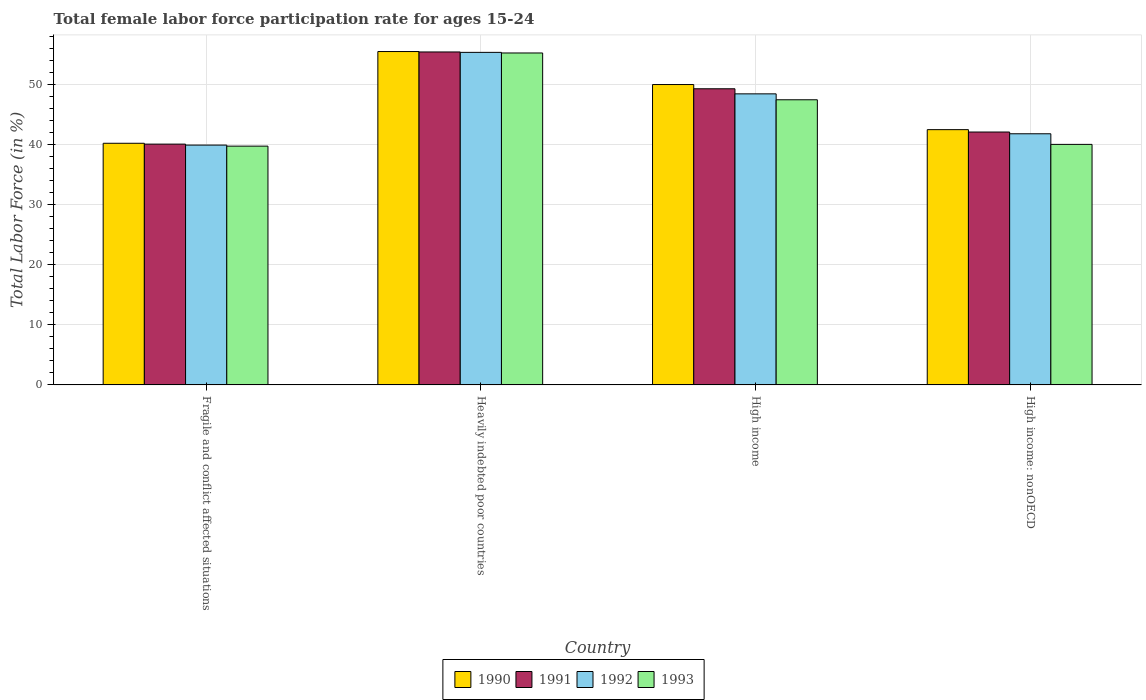How many different coloured bars are there?
Keep it short and to the point. 4. How many bars are there on the 4th tick from the right?
Give a very brief answer. 4. What is the label of the 2nd group of bars from the left?
Ensure brevity in your answer.  Heavily indebted poor countries. What is the female labor force participation rate in 1990 in Heavily indebted poor countries?
Keep it short and to the point. 55.53. Across all countries, what is the maximum female labor force participation rate in 1991?
Give a very brief answer. 55.46. Across all countries, what is the minimum female labor force participation rate in 1992?
Your answer should be very brief. 39.95. In which country was the female labor force participation rate in 1993 maximum?
Make the answer very short. Heavily indebted poor countries. In which country was the female labor force participation rate in 1992 minimum?
Provide a succinct answer. Fragile and conflict affected situations. What is the total female labor force participation rate in 1991 in the graph?
Make the answer very short. 187.02. What is the difference between the female labor force participation rate in 1992 in Heavily indebted poor countries and that in High income: nonOECD?
Provide a short and direct response. 13.56. What is the difference between the female labor force participation rate in 1993 in High income: nonOECD and the female labor force participation rate in 1990 in Fragile and conflict affected situations?
Provide a succinct answer. -0.18. What is the average female labor force participation rate in 1993 per country?
Offer a terse response. 45.66. What is the difference between the female labor force participation rate of/in 1991 and female labor force participation rate of/in 1990 in High income?
Offer a terse response. -0.71. What is the ratio of the female labor force participation rate in 1993 in Heavily indebted poor countries to that in High income: nonOECD?
Your response must be concise. 1.38. Is the female labor force participation rate in 1990 in Fragile and conflict affected situations less than that in Heavily indebted poor countries?
Keep it short and to the point. Yes. What is the difference between the highest and the second highest female labor force participation rate in 1992?
Provide a short and direct response. 6.65. What is the difference between the highest and the lowest female labor force participation rate in 1992?
Offer a very short reply. 15.44. In how many countries, is the female labor force participation rate in 1990 greater than the average female labor force participation rate in 1990 taken over all countries?
Offer a terse response. 2. What does the 3rd bar from the left in High income: nonOECD represents?
Keep it short and to the point. 1992. What does the 2nd bar from the right in Heavily indebted poor countries represents?
Offer a terse response. 1992. How many bars are there?
Make the answer very short. 16. Are all the bars in the graph horizontal?
Give a very brief answer. No. How many countries are there in the graph?
Offer a terse response. 4. Are the values on the major ticks of Y-axis written in scientific E-notation?
Provide a short and direct response. No. Does the graph contain any zero values?
Your answer should be compact. No. Does the graph contain grids?
Provide a short and direct response. Yes. How many legend labels are there?
Provide a succinct answer. 4. How are the legend labels stacked?
Offer a very short reply. Horizontal. What is the title of the graph?
Provide a succinct answer. Total female labor force participation rate for ages 15-24. What is the Total Labor Force (in %) in 1990 in Fragile and conflict affected situations?
Offer a very short reply. 40.25. What is the Total Labor Force (in %) in 1991 in Fragile and conflict affected situations?
Provide a short and direct response. 40.11. What is the Total Labor Force (in %) of 1992 in Fragile and conflict affected situations?
Ensure brevity in your answer.  39.95. What is the Total Labor Force (in %) in 1993 in Fragile and conflict affected situations?
Your response must be concise. 39.77. What is the Total Labor Force (in %) of 1990 in Heavily indebted poor countries?
Keep it short and to the point. 55.53. What is the Total Labor Force (in %) of 1991 in Heavily indebted poor countries?
Keep it short and to the point. 55.46. What is the Total Labor Force (in %) of 1992 in Heavily indebted poor countries?
Keep it short and to the point. 55.39. What is the Total Labor Force (in %) in 1993 in Heavily indebted poor countries?
Your answer should be compact. 55.29. What is the Total Labor Force (in %) of 1990 in High income?
Ensure brevity in your answer.  50.03. What is the Total Labor Force (in %) in 1991 in High income?
Provide a short and direct response. 49.33. What is the Total Labor Force (in %) of 1992 in High income?
Offer a terse response. 48.48. What is the Total Labor Force (in %) of 1993 in High income?
Your response must be concise. 47.5. What is the Total Labor Force (in %) of 1990 in High income: nonOECD?
Offer a terse response. 42.52. What is the Total Labor Force (in %) in 1991 in High income: nonOECD?
Your answer should be compact. 42.12. What is the Total Labor Force (in %) in 1992 in High income: nonOECD?
Keep it short and to the point. 41.83. What is the Total Labor Force (in %) in 1993 in High income: nonOECD?
Give a very brief answer. 40.07. Across all countries, what is the maximum Total Labor Force (in %) of 1990?
Your answer should be very brief. 55.53. Across all countries, what is the maximum Total Labor Force (in %) in 1991?
Your answer should be very brief. 55.46. Across all countries, what is the maximum Total Labor Force (in %) in 1992?
Keep it short and to the point. 55.39. Across all countries, what is the maximum Total Labor Force (in %) of 1993?
Keep it short and to the point. 55.29. Across all countries, what is the minimum Total Labor Force (in %) in 1990?
Make the answer very short. 40.25. Across all countries, what is the minimum Total Labor Force (in %) of 1991?
Your response must be concise. 40.11. Across all countries, what is the minimum Total Labor Force (in %) of 1992?
Provide a short and direct response. 39.95. Across all countries, what is the minimum Total Labor Force (in %) in 1993?
Make the answer very short. 39.77. What is the total Total Labor Force (in %) in 1990 in the graph?
Ensure brevity in your answer.  188.33. What is the total Total Labor Force (in %) of 1991 in the graph?
Make the answer very short. 187.02. What is the total Total Labor Force (in %) in 1992 in the graph?
Your answer should be compact. 185.65. What is the total Total Labor Force (in %) of 1993 in the graph?
Provide a succinct answer. 182.62. What is the difference between the Total Labor Force (in %) in 1990 in Fragile and conflict affected situations and that in Heavily indebted poor countries?
Offer a terse response. -15.28. What is the difference between the Total Labor Force (in %) of 1991 in Fragile and conflict affected situations and that in Heavily indebted poor countries?
Keep it short and to the point. -15.35. What is the difference between the Total Labor Force (in %) in 1992 in Fragile and conflict affected situations and that in Heavily indebted poor countries?
Your response must be concise. -15.44. What is the difference between the Total Labor Force (in %) of 1993 in Fragile and conflict affected situations and that in Heavily indebted poor countries?
Your response must be concise. -15.52. What is the difference between the Total Labor Force (in %) of 1990 in Fragile and conflict affected situations and that in High income?
Make the answer very short. -9.78. What is the difference between the Total Labor Force (in %) in 1991 in Fragile and conflict affected situations and that in High income?
Ensure brevity in your answer.  -9.22. What is the difference between the Total Labor Force (in %) of 1992 in Fragile and conflict affected situations and that in High income?
Your response must be concise. -8.53. What is the difference between the Total Labor Force (in %) in 1993 in Fragile and conflict affected situations and that in High income?
Make the answer very short. -7.72. What is the difference between the Total Labor Force (in %) of 1990 in Fragile and conflict affected situations and that in High income: nonOECD?
Your response must be concise. -2.27. What is the difference between the Total Labor Force (in %) in 1991 in Fragile and conflict affected situations and that in High income: nonOECD?
Provide a succinct answer. -2.01. What is the difference between the Total Labor Force (in %) in 1992 in Fragile and conflict affected situations and that in High income: nonOECD?
Keep it short and to the point. -1.88. What is the difference between the Total Labor Force (in %) in 1993 in Fragile and conflict affected situations and that in High income: nonOECD?
Provide a short and direct response. -0.29. What is the difference between the Total Labor Force (in %) in 1990 in Heavily indebted poor countries and that in High income?
Your answer should be very brief. 5.5. What is the difference between the Total Labor Force (in %) of 1991 in Heavily indebted poor countries and that in High income?
Your answer should be very brief. 6.13. What is the difference between the Total Labor Force (in %) in 1992 in Heavily indebted poor countries and that in High income?
Your response must be concise. 6.91. What is the difference between the Total Labor Force (in %) of 1993 in Heavily indebted poor countries and that in High income?
Your answer should be compact. 7.79. What is the difference between the Total Labor Force (in %) in 1990 in Heavily indebted poor countries and that in High income: nonOECD?
Offer a very short reply. 13.01. What is the difference between the Total Labor Force (in %) in 1991 in Heavily indebted poor countries and that in High income: nonOECD?
Ensure brevity in your answer.  13.34. What is the difference between the Total Labor Force (in %) in 1992 in Heavily indebted poor countries and that in High income: nonOECD?
Your response must be concise. 13.56. What is the difference between the Total Labor Force (in %) of 1993 in Heavily indebted poor countries and that in High income: nonOECD?
Your answer should be compact. 15.22. What is the difference between the Total Labor Force (in %) of 1990 in High income and that in High income: nonOECD?
Give a very brief answer. 7.52. What is the difference between the Total Labor Force (in %) of 1991 in High income and that in High income: nonOECD?
Provide a short and direct response. 7.2. What is the difference between the Total Labor Force (in %) in 1992 in High income and that in High income: nonOECD?
Your answer should be compact. 6.65. What is the difference between the Total Labor Force (in %) in 1993 in High income and that in High income: nonOECD?
Ensure brevity in your answer.  7.43. What is the difference between the Total Labor Force (in %) of 1990 in Fragile and conflict affected situations and the Total Labor Force (in %) of 1991 in Heavily indebted poor countries?
Make the answer very short. -15.21. What is the difference between the Total Labor Force (in %) of 1990 in Fragile and conflict affected situations and the Total Labor Force (in %) of 1992 in Heavily indebted poor countries?
Your answer should be compact. -15.14. What is the difference between the Total Labor Force (in %) in 1990 in Fragile and conflict affected situations and the Total Labor Force (in %) in 1993 in Heavily indebted poor countries?
Provide a succinct answer. -15.04. What is the difference between the Total Labor Force (in %) of 1991 in Fragile and conflict affected situations and the Total Labor Force (in %) of 1992 in Heavily indebted poor countries?
Offer a terse response. -15.28. What is the difference between the Total Labor Force (in %) of 1991 in Fragile and conflict affected situations and the Total Labor Force (in %) of 1993 in Heavily indebted poor countries?
Your answer should be very brief. -15.18. What is the difference between the Total Labor Force (in %) of 1992 in Fragile and conflict affected situations and the Total Labor Force (in %) of 1993 in Heavily indebted poor countries?
Keep it short and to the point. -15.34. What is the difference between the Total Labor Force (in %) in 1990 in Fragile and conflict affected situations and the Total Labor Force (in %) in 1991 in High income?
Make the answer very short. -9.08. What is the difference between the Total Labor Force (in %) of 1990 in Fragile and conflict affected situations and the Total Labor Force (in %) of 1992 in High income?
Offer a very short reply. -8.23. What is the difference between the Total Labor Force (in %) in 1990 in Fragile and conflict affected situations and the Total Labor Force (in %) in 1993 in High income?
Give a very brief answer. -7.24. What is the difference between the Total Labor Force (in %) in 1991 in Fragile and conflict affected situations and the Total Labor Force (in %) in 1992 in High income?
Make the answer very short. -8.37. What is the difference between the Total Labor Force (in %) of 1991 in Fragile and conflict affected situations and the Total Labor Force (in %) of 1993 in High income?
Your answer should be very brief. -7.38. What is the difference between the Total Labor Force (in %) in 1992 in Fragile and conflict affected situations and the Total Labor Force (in %) in 1993 in High income?
Your answer should be compact. -7.55. What is the difference between the Total Labor Force (in %) in 1990 in Fragile and conflict affected situations and the Total Labor Force (in %) in 1991 in High income: nonOECD?
Offer a terse response. -1.87. What is the difference between the Total Labor Force (in %) in 1990 in Fragile and conflict affected situations and the Total Labor Force (in %) in 1992 in High income: nonOECD?
Ensure brevity in your answer.  -1.58. What is the difference between the Total Labor Force (in %) in 1990 in Fragile and conflict affected situations and the Total Labor Force (in %) in 1993 in High income: nonOECD?
Offer a very short reply. 0.18. What is the difference between the Total Labor Force (in %) in 1991 in Fragile and conflict affected situations and the Total Labor Force (in %) in 1992 in High income: nonOECD?
Provide a short and direct response. -1.72. What is the difference between the Total Labor Force (in %) in 1991 in Fragile and conflict affected situations and the Total Labor Force (in %) in 1993 in High income: nonOECD?
Your answer should be very brief. 0.04. What is the difference between the Total Labor Force (in %) of 1992 in Fragile and conflict affected situations and the Total Labor Force (in %) of 1993 in High income: nonOECD?
Ensure brevity in your answer.  -0.12. What is the difference between the Total Labor Force (in %) in 1990 in Heavily indebted poor countries and the Total Labor Force (in %) in 1991 in High income?
Your response must be concise. 6.2. What is the difference between the Total Labor Force (in %) in 1990 in Heavily indebted poor countries and the Total Labor Force (in %) in 1992 in High income?
Ensure brevity in your answer.  7.05. What is the difference between the Total Labor Force (in %) of 1990 in Heavily indebted poor countries and the Total Labor Force (in %) of 1993 in High income?
Provide a short and direct response. 8.03. What is the difference between the Total Labor Force (in %) of 1991 in Heavily indebted poor countries and the Total Labor Force (in %) of 1992 in High income?
Provide a short and direct response. 6.98. What is the difference between the Total Labor Force (in %) of 1991 in Heavily indebted poor countries and the Total Labor Force (in %) of 1993 in High income?
Your response must be concise. 7.96. What is the difference between the Total Labor Force (in %) in 1992 in Heavily indebted poor countries and the Total Labor Force (in %) in 1993 in High income?
Offer a very short reply. 7.9. What is the difference between the Total Labor Force (in %) in 1990 in Heavily indebted poor countries and the Total Labor Force (in %) in 1991 in High income: nonOECD?
Offer a terse response. 13.4. What is the difference between the Total Labor Force (in %) in 1990 in Heavily indebted poor countries and the Total Labor Force (in %) in 1992 in High income: nonOECD?
Your response must be concise. 13.7. What is the difference between the Total Labor Force (in %) of 1990 in Heavily indebted poor countries and the Total Labor Force (in %) of 1993 in High income: nonOECD?
Give a very brief answer. 15.46. What is the difference between the Total Labor Force (in %) of 1991 in Heavily indebted poor countries and the Total Labor Force (in %) of 1992 in High income: nonOECD?
Provide a short and direct response. 13.63. What is the difference between the Total Labor Force (in %) of 1991 in Heavily indebted poor countries and the Total Labor Force (in %) of 1993 in High income: nonOECD?
Your answer should be very brief. 15.39. What is the difference between the Total Labor Force (in %) in 1992 in Heavily indebted poor countries and the Total Labor Force (in %) in 1993 in High income: nonOECD?
Ensure brevity in your answer.  15.33. What is the difference between the Total Labor Force (in %) in 1990 in High income and the Total Labor Force (in %) in 1991 in High income: nonOECD?
Make the answer very short. 7.91. What is the difference between the Total Labor Force (in %) in 1990 in High income and the Total Labor Force (in %) in 1992 in High income: nonOECD?
Keep it short and to the point. 8.2. What is the difference between the Total Labor Force (in %) in 1990 in High income and the Total Labor Force (in %) in 1993 in High income: nonOECD?
Keep it short and to the point. 9.97. What is the difference between the Total Labor Force (in %) in 1991 in High income and the Total Labor Force (in %) in 1992 in High income: nonOECD?
Provide a short and direct response. 7.5. What is the difference between the Total Labor Force (in %) of 1991 in High income and the Total Labor Force (in %) of 1993 in High income: nonOECD?
Offer a very short reply. 9.26. What is the difference between the Total Labor Force (in %) in 1992 in High income and the Total Labor Force (in %) in 1993 in High income: nonOECD?
Offer a terse response. 8.42. What is the average Total Labor Force (in %) of 1990 per country?
Offer a very short reply. 47.08. What is the average Total Labor Force (in %) in 1991 per country?
Ensure brevity in your answer.  46.76. What is the average Total Labor Force (in %) of 1992 per country?
Offer a terse response. 46.41. What is the average Total Labor Force (in %) in 1993 per country?
Provide a short and direct response. 45.66. What is the difference between the Total Labor Force (in %) in 1990 and Total Labor Force (in %) in 1991 in Fragile and conflict affected situations?
Ensure brevity in your answer.  0.14. What is the difference between the Total Labor Force (in %) of 1990 and Total Labor Force (in %) of 1992 in Fragile and conflict affected situations?
Ensure brevity in your answer.  0.3. What is the difference between the Total Labor Force (in %) in 1990 and Total Labor Force (in %) in 1993 in Fragile and conflict affected situations?
Give a very brief answer. 0.48. What is the difference between the Total Labor Force (in %) in 1991 and Total Labor Force (in %) in 1992 in Fragile and conflict affected situations?
Provide a short and direct response. 0.16. What is the difference between the Total Labor Force (in %) in 1991 and Total Labor Force (in %) in 1993 in Fragile and conflict affected situations?
Offer a terse response. 0.34. What is the difference between the Total Labor Force (in %) of 1992 and Total Labor Force (in %) of 1993 in Fragile and conflict affected situations?
Provide a succinct answer. 0.18. What is the difference between the Total Labor Force (in %) in 1990 and Total Labor Force (in %) in 1991 in Heavily indebted poor countries?
Offer a very short reply. 0.07. What is the difference between the Total Labor Force (in %) in 1990 and Total Labor Force (in %) in 1992 in Heavily indebted poor countries?
Your answer should be compact. 0.14. What is the difference between the Total Labor Force (in %) of 1990 and Total Labor Force (in %) of 1993 in Heavily indebted poor countries?
Your answer should be very brief. 0.24. What is the difference between the Total Labor Force (in %) in 1991 and Total Labor Force (in %) in 1992 in Heavily indebted poor countries?
Offer a terse response. 0.07. What is the difference between the Total Labor Force (in %) in 1991 and Total Labor Force (in %) in 1993 in Heavily indebted poor countries?
Give a very brief answer. 0.17. What is the difference between the Total Labor Force (in %) of 1992 and Total Labor Force (in %) of 1993 in Heavily indebted poor countries?
Keep it short and to the point. 0.1. What is the difference between the Total Labor Force (in %) in 1990 and Total Labor Force (in %) in 1991 in High income?
Provide a short and direct response. 0.71. What is the difference between the Total Labor Force (in %) in 1990 and Total Labor Force (in %) in 1992 in High income?
Give a very brief answer. 1.55. What is the difference between the Total Labor Force (in %) of 1990 and Total Labor Force (in %) of 1993 in High income?
Ensure brevity in your answer.  2.54. What is the difference between the Total Labor Force (in %) in 1991 and Total Labor Force (in %) in 1992 in High income?
Provide a succinct answer. 0.85. What is the difference between the Total Labor Force (in %) of 1991 and Total Labor Force (in %) of 1993 in High income?
Your response must be concise. 1.83. What is the difference between the Total Labor Force (in %) in 1992 and Total Labor Force (in %) in 1993 in High income?
Give a very brief answer. 0.99. What is the difference between the Total Labor Force (in %) of 1990 and Total Labor Force (in %) of 1991 in High income: nonOECD?
Your answer should be very brief. 0.39. What is the difference between the Total Labor Force (in %) in 1990 and Total Labor Force (in %) in 1992 in High income: nonOECD?
Your answer should be compact. 0.69. What is the difference between the Total Labor Force (in %) of 1990 and Total Labor Force (in %) of 1993 in High income: nonOECD?
Provide a succinct answer. 2.45. What is the difference between the Total Labor Force (in %) of 1991 and Total Labor Force (in %) of 1992 in High income: nonOECD?
Give a very brief answer. 0.29. What is the difference between the Total Labor Force (in %) in 1991 and Total Labor Force (in %) in 1993 in High income: nonOECD?
Offer a very short reply. 2.06. What is the difference between the Total Labor Force (in %) in 1992 and Total Labor Force (in %) in 1993 in High income: nonOECD?
Your answer should be very brief. 1.77. What is the ratio of the Total Labor Force (in %) of 1990 in Fragile and conflict affected situations to that in Heavily indebted poor countries?
Keep it short and to the point. 0.72. What is the ratio of the Total Labor Force (in %) of 1991 in Fragile and conflict affected situations to that in Heavily indebted poor countries?
Provide a short and direct response. 0.72. What is the ratio of the Total Labor Force (in %) of 1992 in Fragile and conflict affected situations to that in Heavily indebted poor countries?
Give a very brief answer. 0.72. What is the ratio of the Total Labor Force (in %) in 1993 in Fragile and conflict affected situations to that in Heavily indebted poor countries?
Provide a succinct answer. 0.72. What is the ratio of the Total Labor Force (in %) in 1990 in Fragile and conflict affected situations to that in High income?
Your answer should be very brief. 0.8. What is the ratio of the Total Labor Force (in %) of 1991 in Fragile and conflict affected situations to that in High income?
Your answer should be very brief. 0.81. What is the ratio of the Total Labor Force (in %) of 1992 in Fragile and conflict affected situations to that in High income?
Offer a very short reply. 0.82. What is the ratio of the Total Labor Force (in %) of 1993 in Fragile and conflict affected situations to that in High income?
Offer a very short reply. 0.84. What is the ratio of the Total Labor Force (in %) in 1990 in Fragile and conflict affected situations to that in High income: nonOECD?
Give a very brief answer. 0.95. What is the ratio of the Total Labor Force (in %) of 1991 in Fragile and conflict affected situations to that in High income: nonOECD?
Your response must be concise. 0.95. What is the ratio of the Total Labor Force (in %) in 1992 in Fragile and conflict affected situations to that in High income: nonOECD?
Offer a very short reply. 0.95. What is the ratio of the Total Labor Force (in %) of 1990 in Heavily indebted poor countries to that in High income?
Give a very brief answer. 1.11. What is the ratio of the Total Labor Force (in %) in 1991 in Heavily indebted poor countries to that in High income?
Your response must be concise. 1.12. What is the ratio of the Total Labor Force (in %) of 1992 in Heavily indebted poor countries to that in High income?
Ensure brevity in your answer.  1.14. What is the ratio of the Total Labor Force (in %) in 1993 in Heavily indebted poor countries to that in High income?
Keep it short and to the point. 1.16. What is the ratio of the Total Labor Force (in %) in 1990 in Heavily indebted poor countries to that in High income: nonOECD?
Ensure brevity in your answer.  1.31. What is the ratio of the Total Labor Force (in %) in 1991 in Heavily indebted poor countries to that in High income: nonOECD?
Offer a terse response. 1.32. What is the ratio of the Total Labor Force (in %) of 1992 in Heavily indebted poor countries to that in High income: nonOECD?
Keep it short and to the point. 1.32. What is the ratio of the Total Labor Force (in %) in 1993 in Heavily indebted poor countries to that in High income: nonOECD?
Ensure brevity in your answer.  1.38. What is the ratio of the Total Labor Force (in %) of 1990 in High income to that in High income: nonOECD?
Provide a succinct answer. 1.18. What is the ratio of the Total Labor Force (in %) of 1991 in High income to that in High income: nonOECD?
Make the answer very short. 1.17. What is the ratio of the Total Labor Force (in %) of 1992 in High income to that in High income: nonOECD?
Your response must be concise. 1.16. What is the ratio of the Total Labor Force (in %) of 1993 in High income to that in High income: nonOECD?
Provide a short and direct response. 1.19. What is the difference between the highest and the second highest Total Labor Force (in %) in 1990?
Offer a very short reply. 5.5. What is the difference between the highest and the second highest Total Labor Force (in %) in 1991?
Your answer should be very brief. 6.13. What is the difference between the highest and the second highest Total Labor Force (in %) in 1992?
Your answer should be very brief. 6.91. What is the difference between the highest and the second highest Total Labor Force (in %) of 1993?
Your answer should be compact. 7.79. What is the difference between the highest and the lowest Total Labor Force (in %) in 1990?
Offer a terse response. 15.28. What is the difference between the highest and the lowest Total Labor Force (in %) of 1991?
Offer a terse response. 15.35. What is the difference between the highest and the lowest Total Labor Force (in %) of 1992?
Your response must be concise. 15.44. What is the difference between the highest and the lowest Total Labor Force (in %) of 1993?
Make the answer very short. 15.52. 